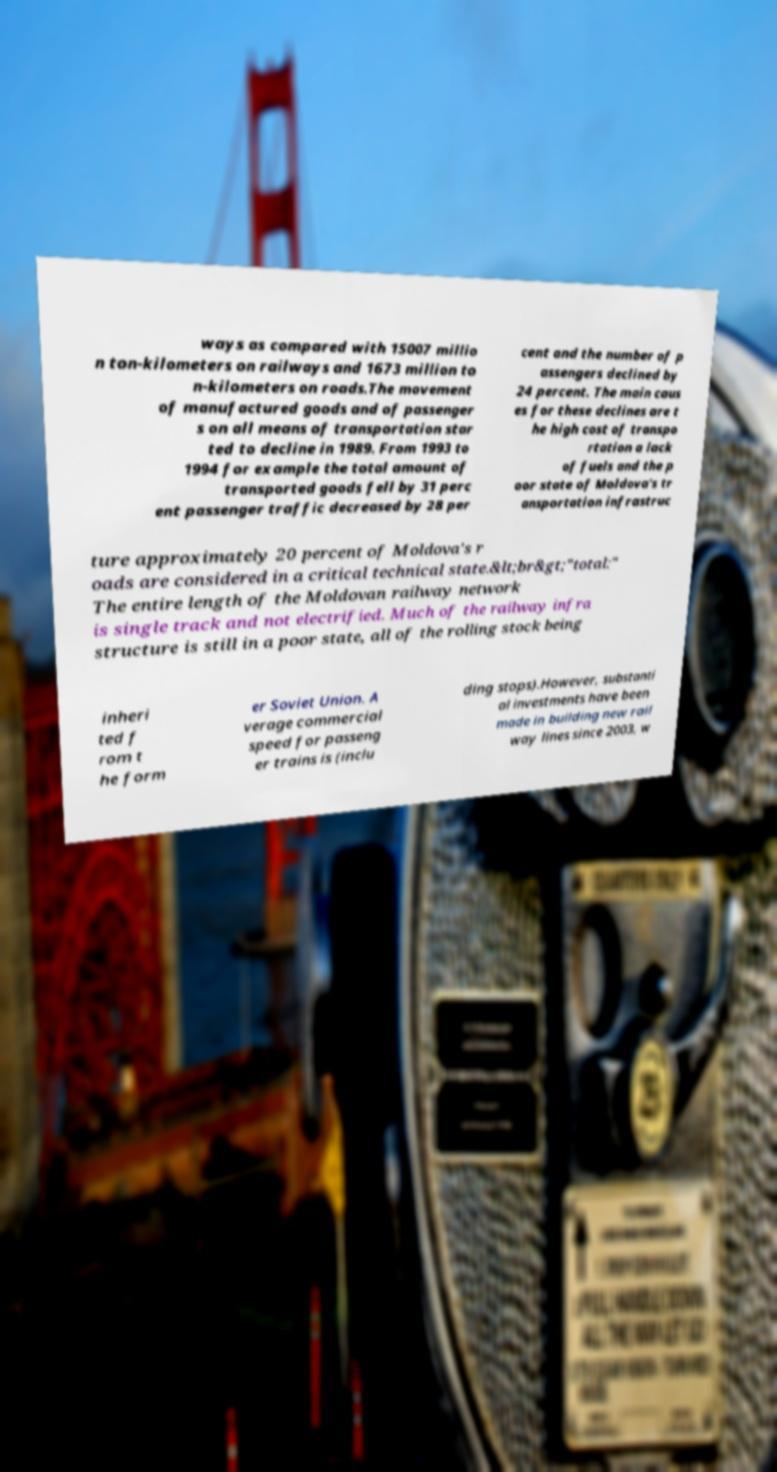Please identify and transcribe the text found in this image. ways as compared with 15007 millio n ton-kilometers on railways and 1673 million to n-kilometers on roads.The movement of manufactured goods and of passenger s on all means of transportation star ted to decline in 1989. From 1993 to 1994 for example the total amount of transported goods fell by 31 perc ent passenger traffic decreased by 28 per cent and the number of p assengers declined by 24 percent. The main caus es for these declines are t he high cost of transpo rtation a lack of fuels and the p oor state of Moldova's tr ansportation infrastruc ture approximately 20 percent of Moldova's r oads are considered in a critical technical state.&lt;br&gt;"total:" The entire length of the Moldovan railway network is single track and not electrified. Much of the railway infra structure is still in a poor state, all of the rolling stock being inheri ted f rom t he form er Soviet Union. A verage commercial speed for passeng er trains is (inclu ding stops).However, substanti al investments have been made in building new rail way lines since 2003, w 